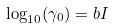Convert formula to latex. <formula><loc_0><loc_0><loc_500><loc_500>\log _ { 1 0 } ( \gamma _ { 0 } ) = b I</formula> 